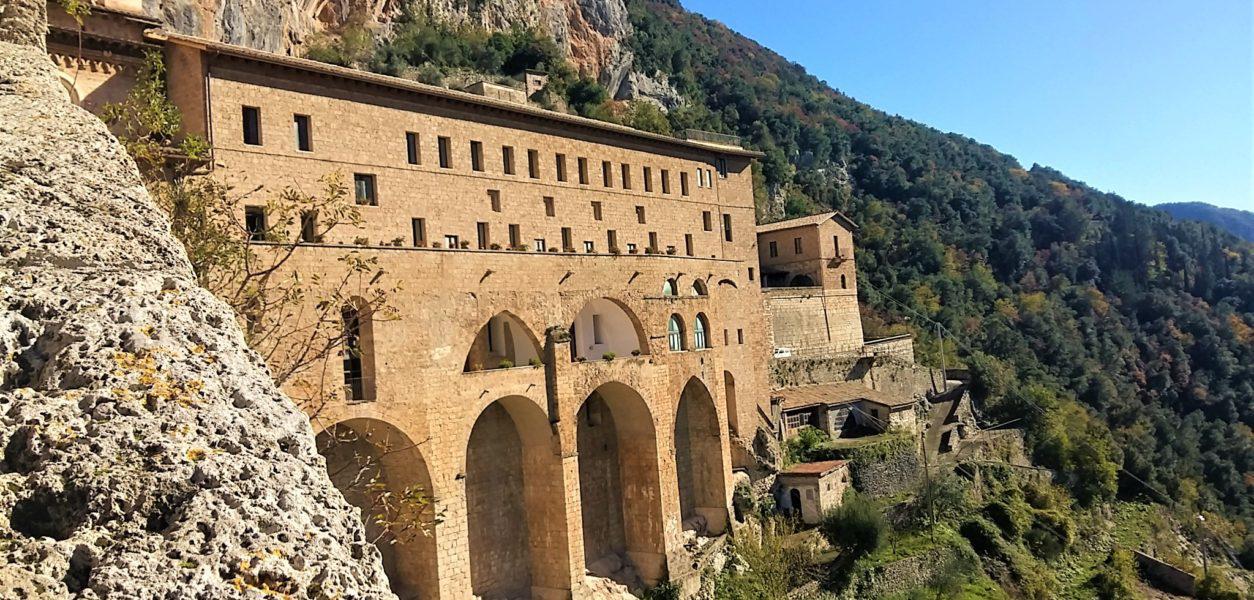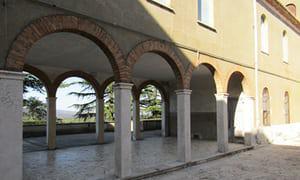The first image is the image on the left, the second image is the image on the right. Analyze the images presented: Is the assertion "In at least one image there is a building built out of white brick carved in to the side of a mountain." valid? Answer yes or no. No. 